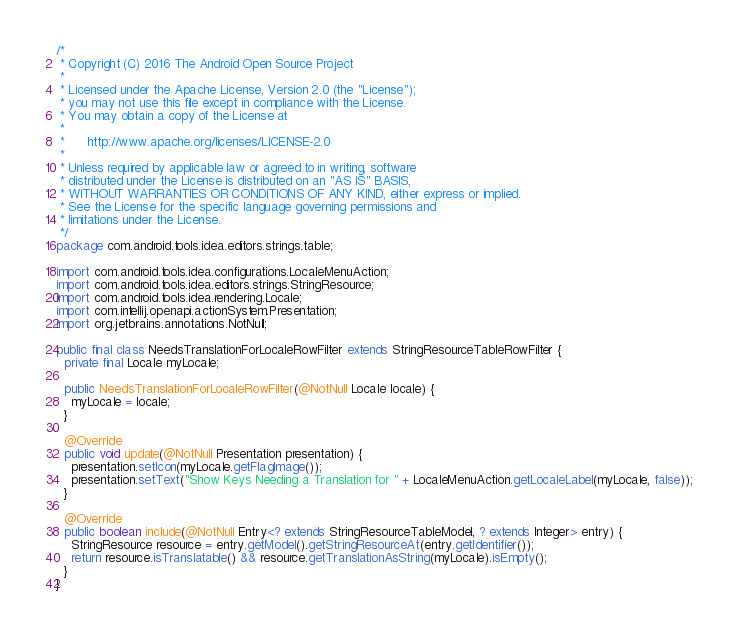<code> <loc_0><loc_0><loc_500><loc_500><_Java_>/*
 * Copyright (C) 2016 The Android Open Source Project
 *
 * Licensed under the Apache License, Version 2.0 (the "License");
 * you may not use this file except in compliance with the License.
 * You may obtain a copy of the License at
 *
 *      http://www.apache.org/licenses/LICENSE-2.0
 *
 * Unless required by applicable law or agreed to in writing, software
 * distributed under the License is distributed on an "AS IS" BASIS,
 * WITHOUT WARRANTIES OR CONDITIONS OF ANY KIND, either express or implied.
 * See the License for the specific language governing permissions and
 * limitations under the License.
 */
package com.android.tools.idea.editors.strings.table;

import com.android.tools.idea.configurations.LocaleMenuAction;
import com.android.tools.idea.editors.strings.StringResource;
import com.android.tools.idea.rendering.Locale;
import com.intellij.openapi.actionSystem.Presentation;
import org.jetbrains.annotations.NotNull;

public final class NeedsTranslationForLocaleRowFilter extends StringResourceTableRowFilter {
  private final Locale myLocale;

  public NeedsTranslationForLocaleRowFilter(@NotNull Locale locale) {
    myLocale = locale;
  }

  @Override
  public void update(@NotNull Presentation presentation) {
    presentation.setIcon(myLocale.getFlagImage());
    presentation.setText("Show Keys Needing a Translation for " + LocaleMenuAction.getLocaleLabel(myLocale, false));
  }

  @Override
  public boolean include(@NotNull Entry<? extends StringResourceTableModel, ? extends Integer> entry) {
    StringResource resource = entry.getModel().getStringResourceAt(entry.getIdentifier());
    return resource.isTranslatable() && resource.getTranslationAsString(myLocale).isEmpty();
  }
}
</code> 